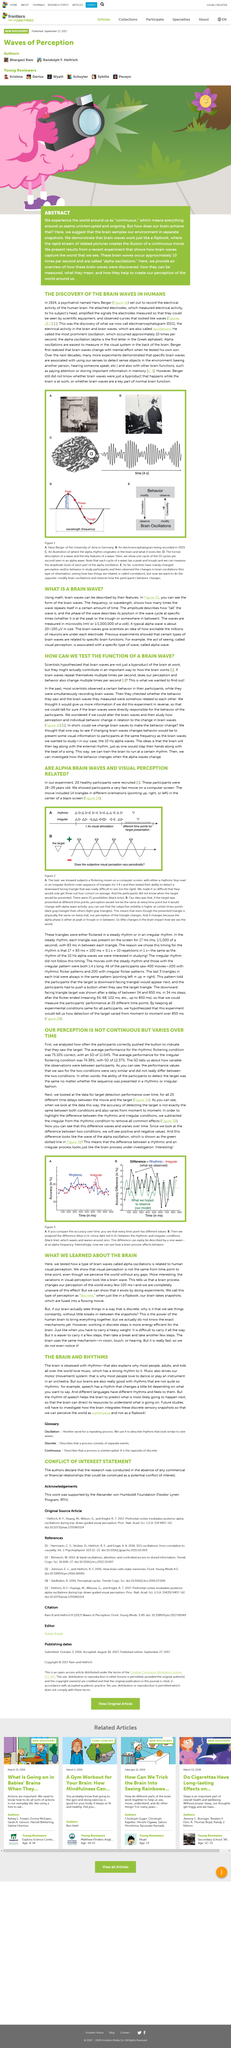Specify some key components in this picture. The title of the article is "ARE ALPHA BRAIN WAVES AND VISUAL PERCEPTION RELATED?". The average performance for the rhythmic flickering condition was 75.10% correct, with a standard deviation of 11.04%. This article discusses the topic of alpha brain waves and their impact on visual perception. The performance values for the two conditions were similar and not significantly different from each other. The person pictured is Hans Berger. 